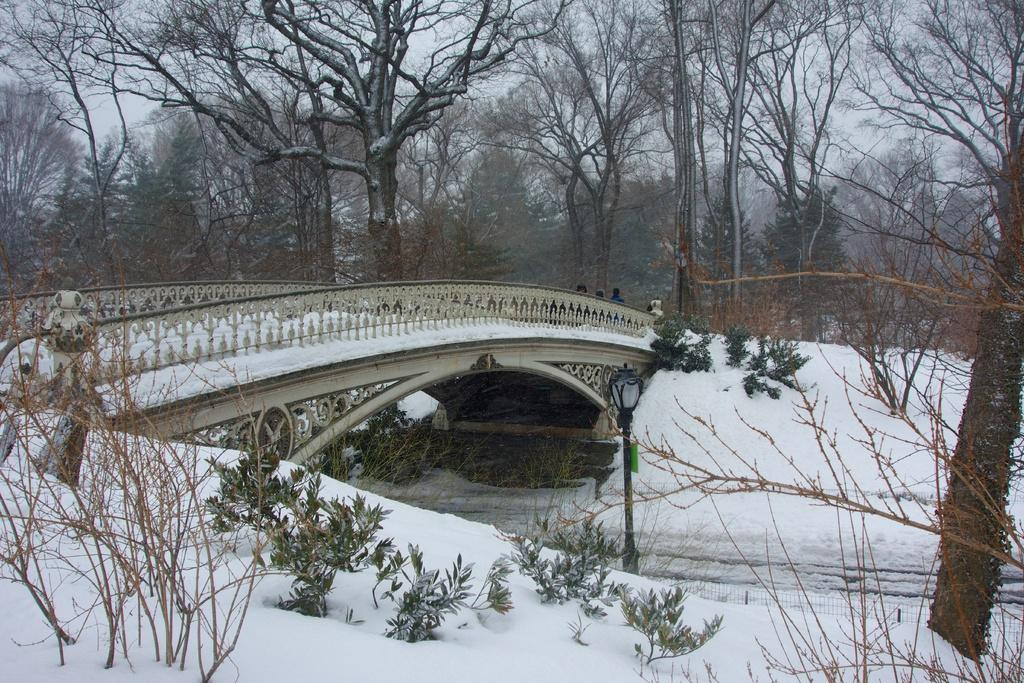What structure is located on the left side of the image? There is a bridge on the left side of the image. What type of weather is depicted in the image? Snow is visible in the image, indicating a snowy or wintry scene. What type of vegetation is at the bottom of the image? There are plants at the bottom of the image. What can be seen in the background of the image? There are trees, people, and the sky visible in the background of the image. Where is the spot where people can make a wish in the image? There is no spot for making wishes present in the image. What type of arch can be seen in the image? There is no arch present in the image. 